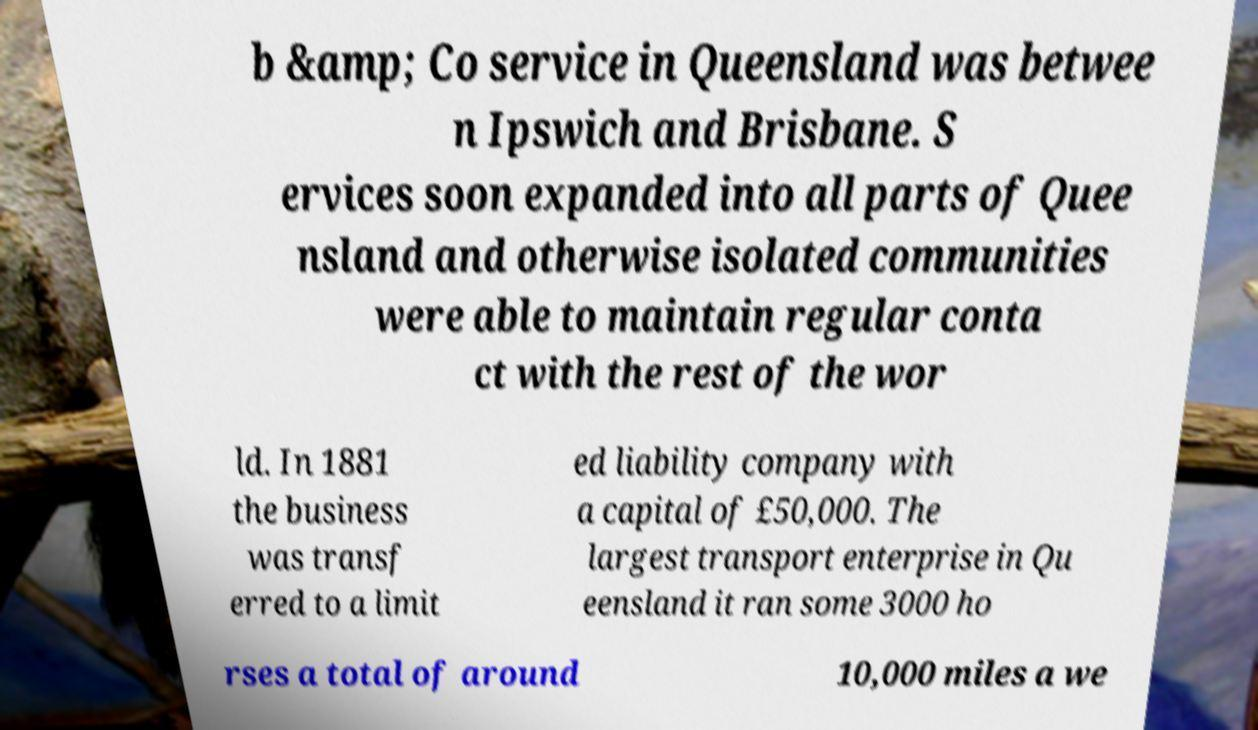What messages or text are displayed in this image? I need them in a readable, typed format. b &amp; Co service in Queensland was betwee n Ipswich and Brisbane. S ervices soon expanded into all parts of Quee nsland and otherwise isolated communities were able to maintain regular conta ct with the rest of the wor ld. In 1881 the business was transf erred to a limit ed liability company with a capital of £50,000. The largest transport enterprise in Qu eensland it ran some 3000 ho rses a total of around 10,000 miles a we 